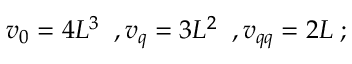<formula> <loc_0><loc_0><loc_500><loc_500>v _ { 0 } = 4 L ^ { 3 } \, , v _ { q } = 3 L ^ { 2 } \, , v _ { q q } = 2 L \, ;</formula> 